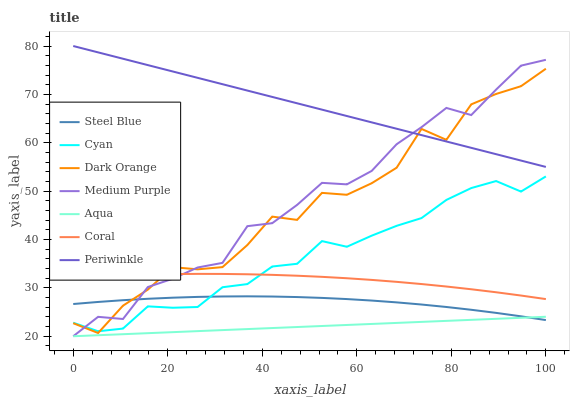Does Aqua have the minimum area under the curve?
Answer yes or no. Yes. Does Periwinkle have the maximum area under the curve?
Answer yes or no. Yes. Does Coral have the minimum area under the curve?
Answer yes or no. No. Does Coral have the maximum area under the curve?
Answer yes or no. No. Is Aqua the smoothest?
Answer yes or no. Yes. Is Dark Orange the roughest?
Answer yes or no. Yes. Is Coral the smoothest?
Answer yes or no. No. Is Coral the roughest?
Answer yes or no. No. Does Aqua have the lowest value?
Answer yes or no. Yes. Does Coral have the lowest value?
Answer yes or no. No. Does Periwinkle have the highest value?
Answer yes or no. Yes. Does Coral have the highest value?
Answer yes or no. No. Is Coral less than Periwinkle?
Answer yes or no. Yes. Is Periwinkle greater than Aqua?
Answer yes or no. Yes. Does Medium Purple intersect Steel Blue?
Answer yes or no. Yes. Is Medium Purple less than Steel Blue?
Answer yes or no. No. Is Medium Purple greater than Steel Blue?
Answer yes or no. No. Does Coral intersect Periwinkle?
Answer yes or no. No. 